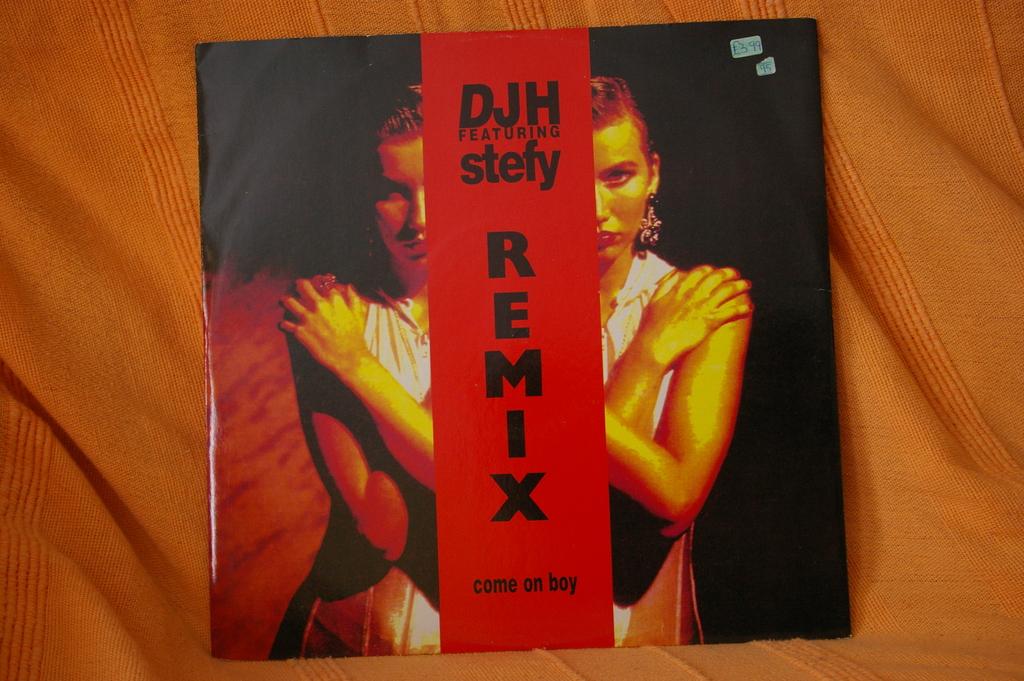Have they made changes to the music?
Provide a short and direct response. Unanswerable. 